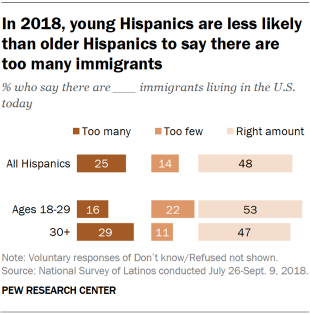Identify some key points in this picture. A recent survey found that approximately 25% of all Hispanics believe that there are too many immigrants currently living in the United States. The median of the pink bars is taken, divided in half, and the resulting value is compared to the largest value of the orange bar. If the result is greater than the largest value of the orange bar, then the process is repeated. 